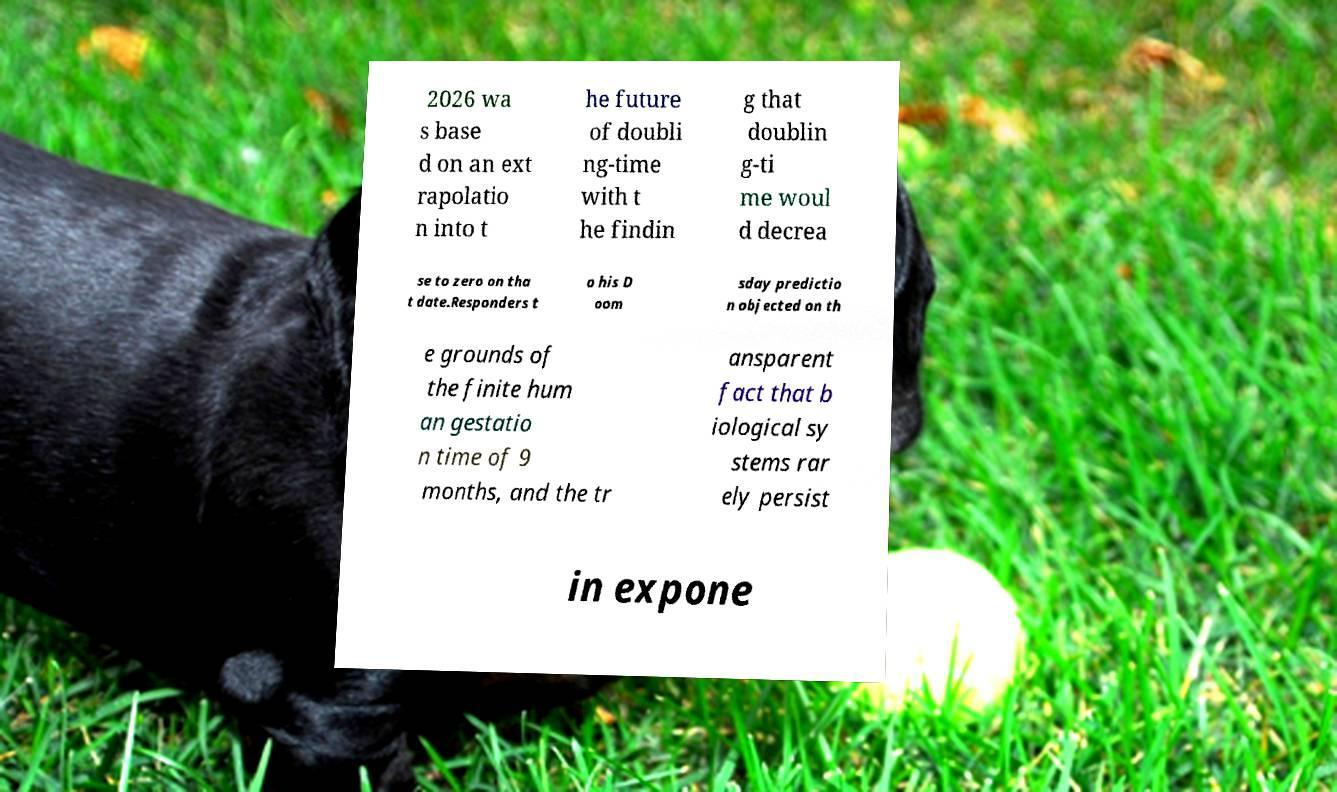Can you accurately transcribe the text from the provided image for me? 2026 wa s base d on an ext rapolatio n into t he future of doubli ng-time with t he findin g that doublin g-ti me woul d decrea se to zero on tha t date.Responders t o his D oom sday predictio n objected on th e grounds of the finite hum an gestatio n time of 9 months, and the tr ansparent fact that b iological sy stems rar ely persist in expone 